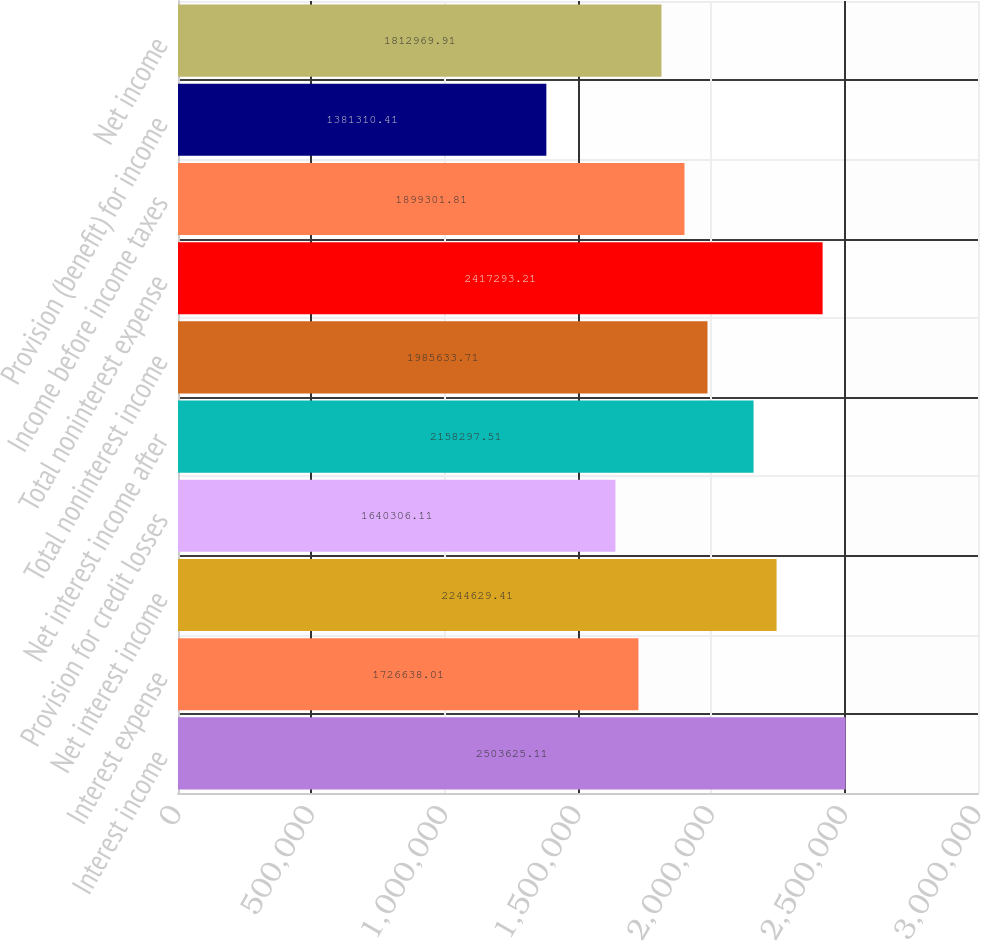Convert chart to OTSL. <chart><loc_0><loc_0><loc_500><loc_500><bar_chart><fcel>Interest income<fcel>Interest expense<fcel>Net interest income<fcel>Provision for credit losses<fcel>Net interest income after<fcel>Total noninterest income<fcel>Total noninterest expense<fcel>Income before income taxes<fcel>Provision (benefit) for income<fcel>Net income<nl><fcel>2.50363e+06<fcel>1.72664e+06<fcel>2.24463e+06<fcel>1.64031e+06<fcel>2.1583e+06<fcel>1.98563e+06<fcel>2.41729e+06<fcel>1.8993e+06<fcel>1.38131e+06<fcel>1.81297e+06<nl></chart> 